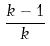<formula> <loc_0><loc_0><loc_500><loc_500>\frac { k - 1 } { k }</formula> 